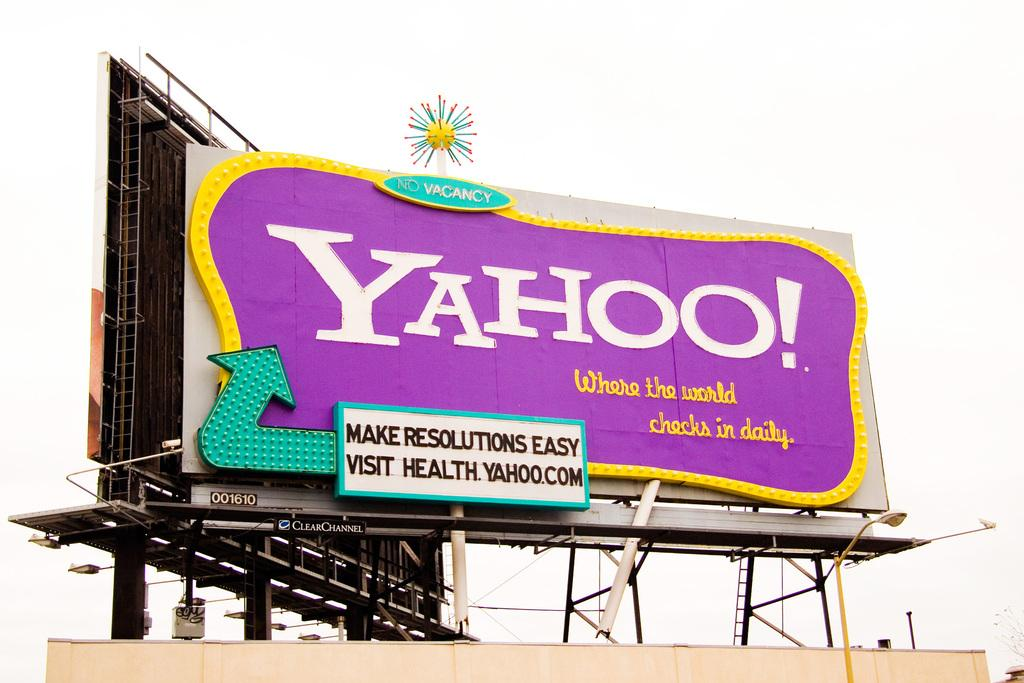<image>
Relay a brief, clear account of the picture shown. A pink, blue and yellow billboard is pushing the Yahoo! brand. 